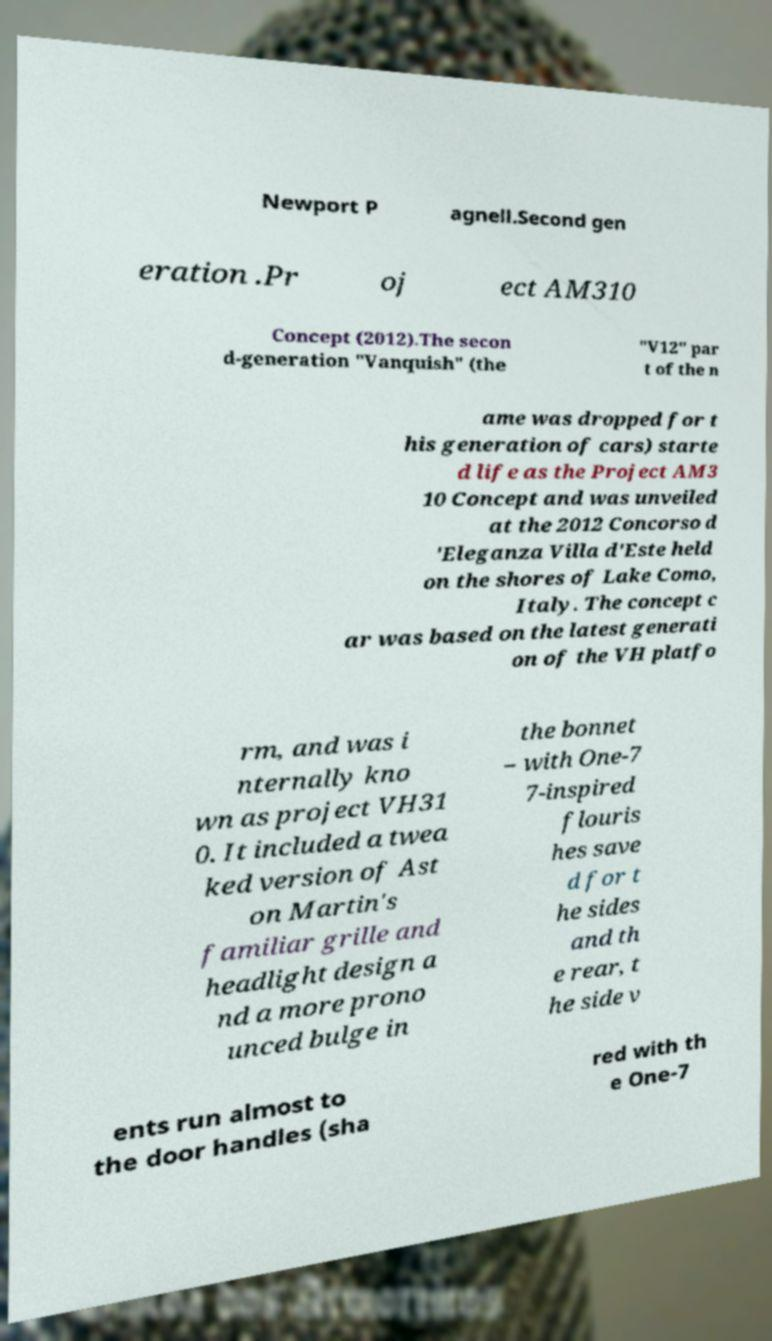Please identify and transcribe the text found in this image. Newport P agnell.Second gen eration .Pr oj ect AM310 Concept (2012).The secon d-generation "Vanquish" (the "V12" par t of the n ame was dropped for t his generation of cars) starte d life as the Project AM3 10 Concept and was unveiled at the 2012 Concorso d 'Eleganza Villa d'Este held on the shores of Lake Como, Italy. The concept c ar was based on the latest generati on of the VH platfo rm, and was i nternally kno wn as project VH31 0. It included a twea ked version of Ast on Martin's familiar grille and headlight design a nd a more prono unced bulge in the bonnet – with One-7 7-inspired flouris hes save d for t he sides and th e rear, t he side v ents run almost to the door handles (sha red with th e One-7 